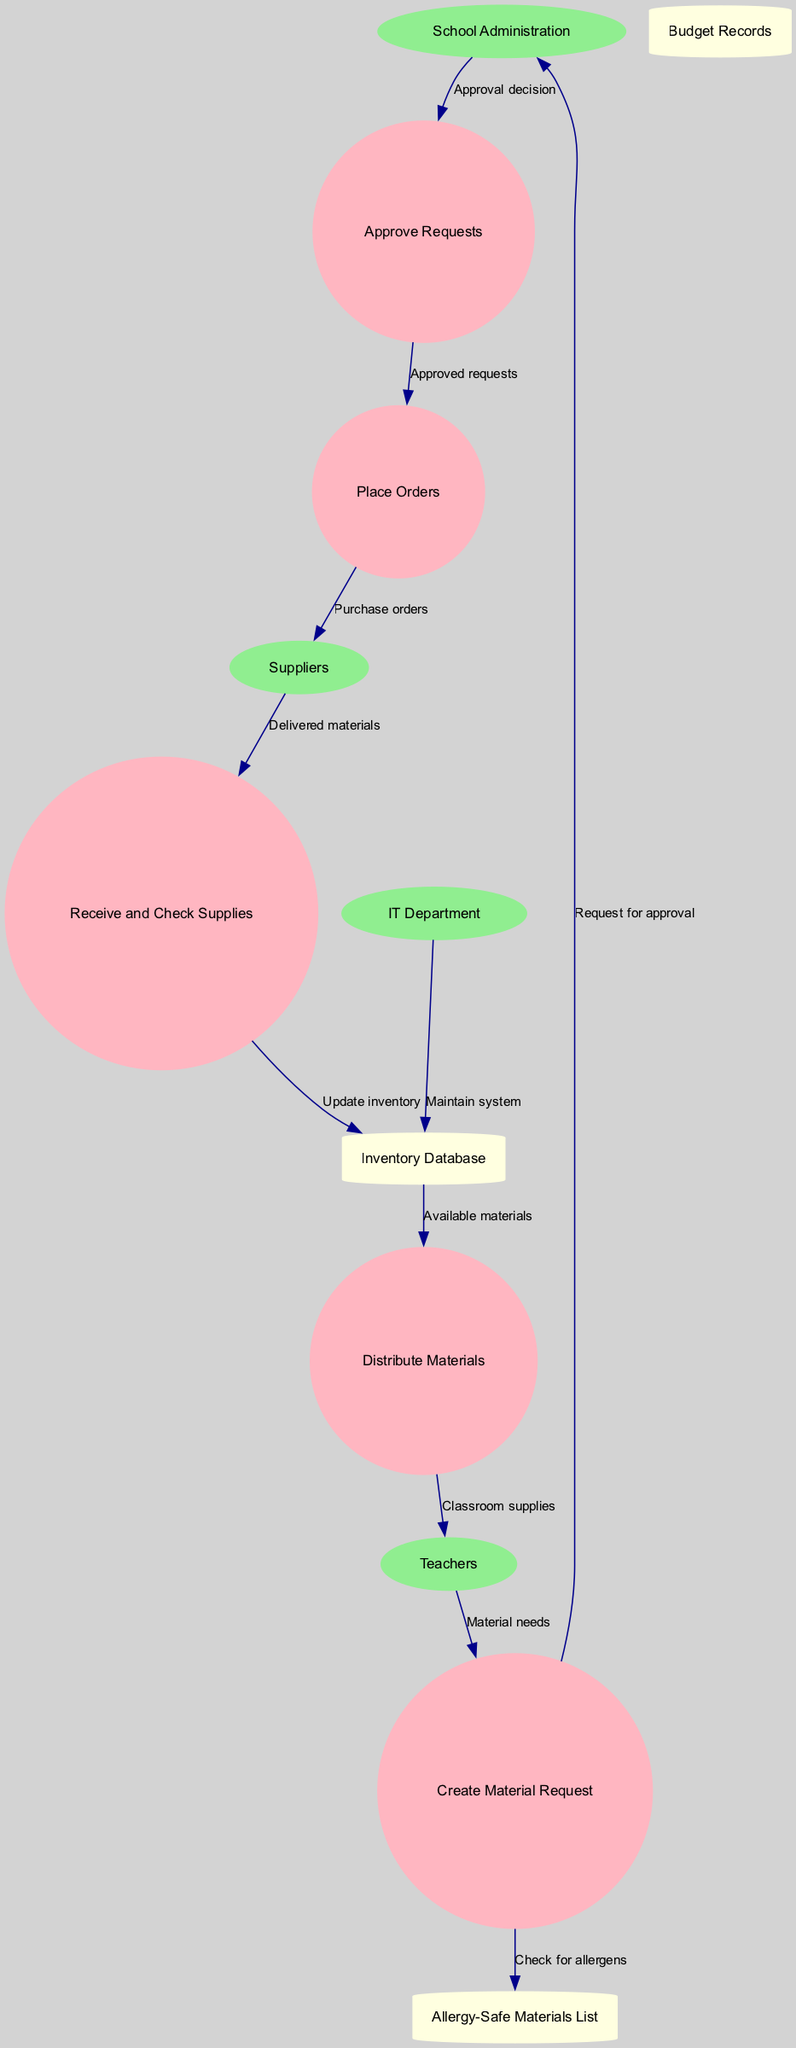What are the external entities in this diagram? The external entities listed in the diagram are "School Administration," "Suppliers," "Teachers," and "IT Department." These are the entities that interact with the processes in the material requisition and distribution system.
Answer: School Administration, Suppliers, Teachers, IT Department How many processes are there in the diagram? The diagram outlines a total of five processes: "Create Material Request," "Approve Requests," "Place Orders," "Receive and Check Supplies," and "Distribute Materials." Counting each of these gives a total of five.
Answer: 5 Which process follows "Approve Requests"? In the diagram, the process that follows "Approve Requests" is "Place Orders." The flow shows that once requests are approved, they move to the order placement stage.
Answer: Place Orders What data store is updated after receiving supplies? After supplies are received, the process "Receive and Check Supplies" updates the "Inventory Database." This step ensures that the inventory reflects the newly received materials.
Answer: Inventory Database What is checked when creating a material request? When creating a material request, the diagram indicates that there is a need to "Check for allergens" by referring to the "Allergy-Safe Materials List." This ensures that the requested materials do not contain allergens.
Answer: Check for allergens Which entity provides the approval decision? The "School Administration" is responsible for providing the approval decision in the diagram. The flow indicates that after receiving the request, they evaluate and decide on the approval.
Answer: School Administration What is the last process before materials are given to teachers? The last process before materials are distributed to teachers is "Distribute Materials." This step involves handing out the classroom supplies after they have been processed through the previous stages.
Answer: Distribute Materials Which department maintains the inventory system? The "IT Department" is tasked with maintaining the "Inventory Database," as indicated by the data flow that connects these two entities in the diagram.
Answer: IT Department What type of data store is the "Allergy-Safe Materials List"? The "Allergy-Safe Materials List" is classified as a data store in the diagram and is represented as a cylinder, which signifies that it stores data relevant to the process flow.
Answer: Data store 